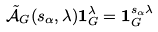<formula> <loc_0><loc_0><loc_500><loc_500>\tilde { \mathcal { A } } _ { G } ( s _ { \alpha } , \lambda ) \mathbf 1 _ { G } ^ { \lambda } = \mathbf 1 _ { G } ^ { s _ { \alpha } \lambda }</formula> 